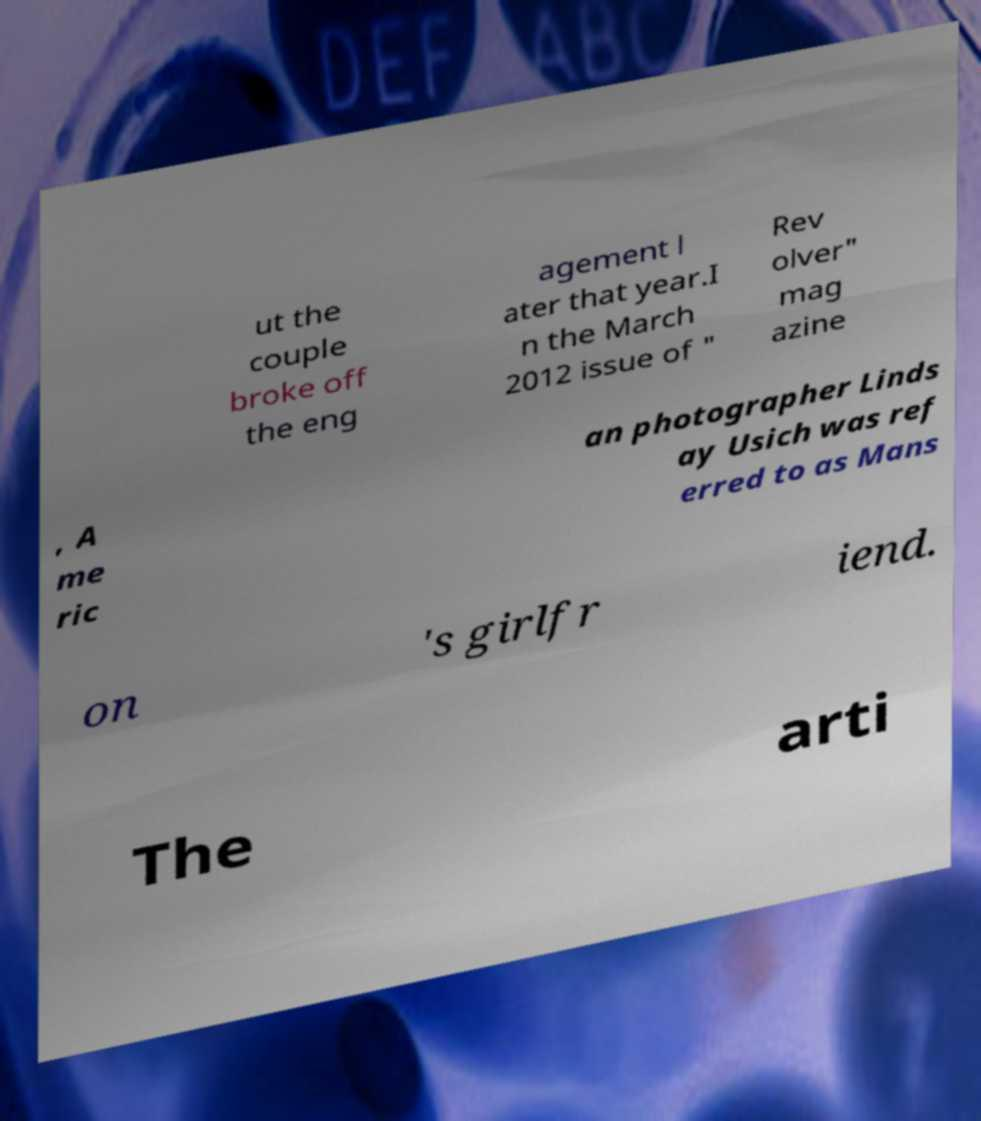For documentation purposes, I need the text within this image transcribed. Could you provide that? ut the couple broke off the eng agement l ater that year.I n the March 2012 issue of " Rev olver" mag azine , A me ric an photographer Linds ay Usich was ref erred to as Mans on 's girlfr iend. The arti 